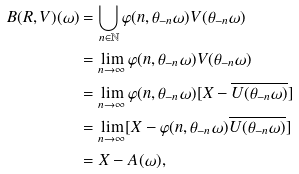<formula> <loc_0><loc_0><loc_500><loc_500>B ( R , V ) ( \omega ) & = \bigcup _ { n \in \mathbb { N } } \varphi ( n , \theta _ { - n } \omega ) V ( \theta _ { - n } \omega ) \\ & = \lim _ { n \rightarrow \infty } \varphi ( n , \theta _ { - n } \omega ) V ( \theta _ { - n } \omega ) \\ & = \lim _ { n \rightarrow \infty } \varphi ( n , \theta _ { - n } \omega ) [ X - \overline { U ( \theta _ { - n } \omega ) } ] \\ & = \lim _ { n \rightarrow \infty } [ X - \varphi ( n , \theta _ { - n } \omega ) \overline { U ( \theta _ { - n } \omega ) } ] \\ & = X - A ( \omega ) ,</formula> 